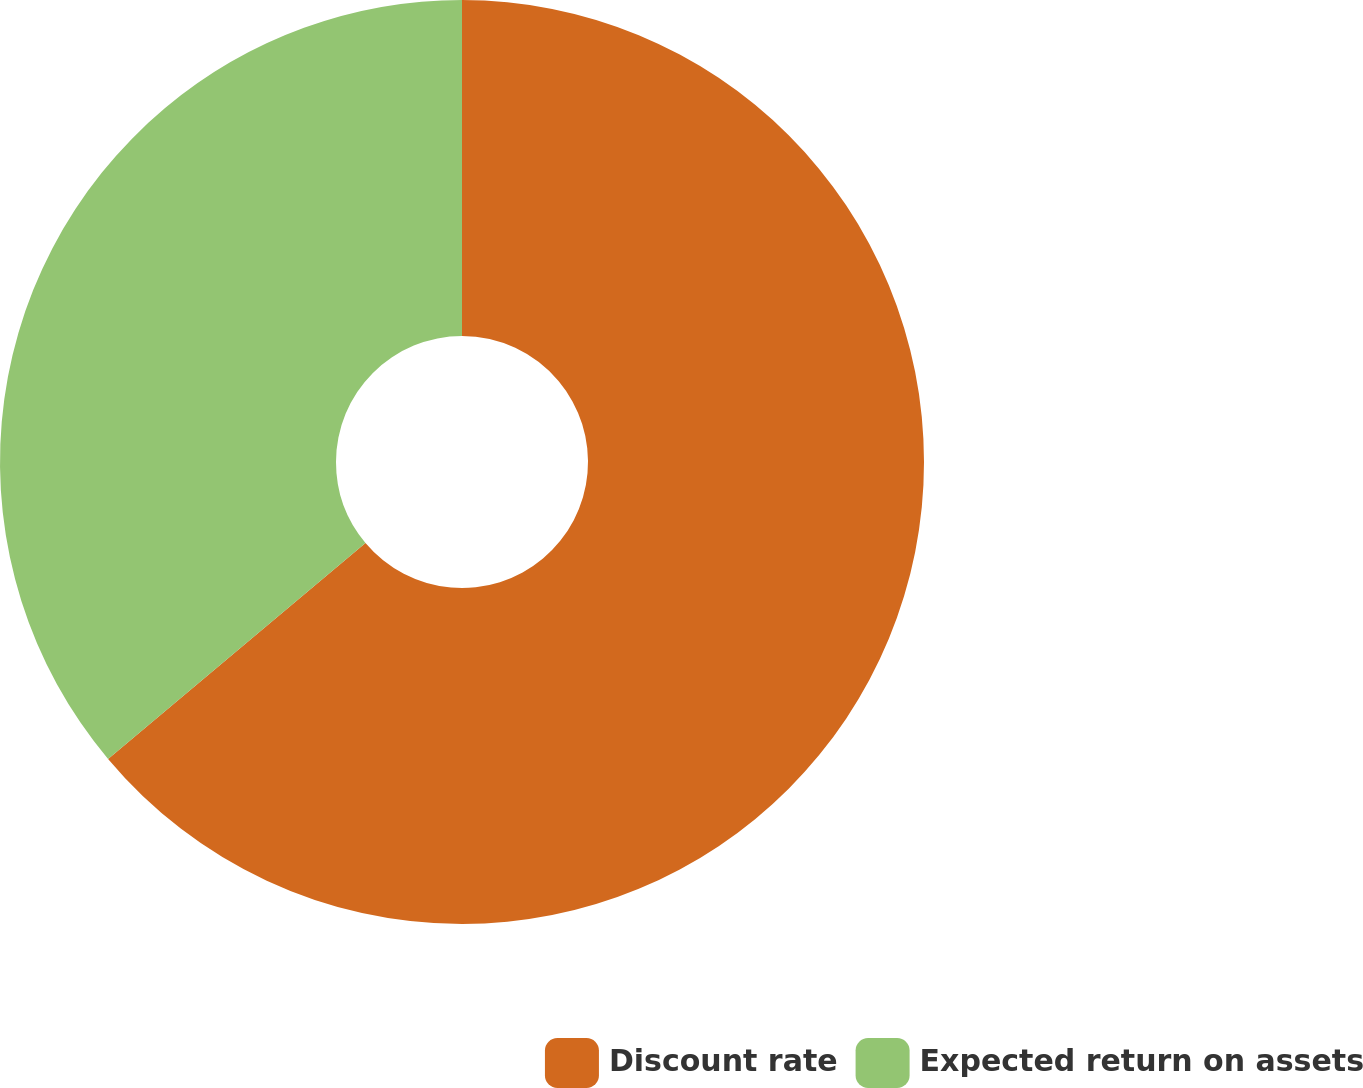<chart> <loc_0><loc_0><loc_500><loc_500><pie_chart><fcel>Discount rate<fcel>Expected return on assets<nl><fcel>63.89%<fcel>36.11%<nl></chart> 